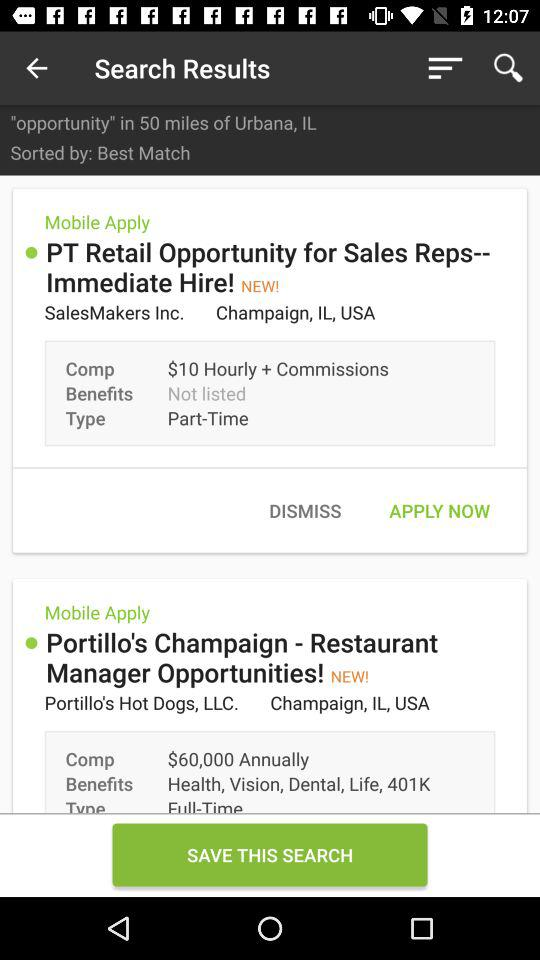What type of job is available in "PT Retail"? The type of job is "Part-Time". 